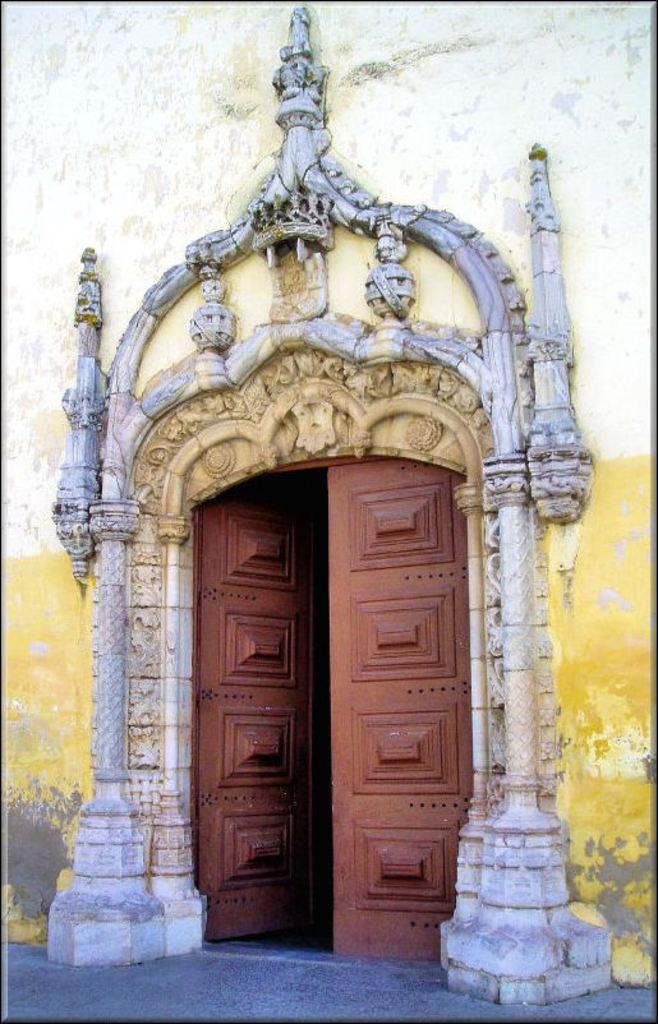What type of structure is visible in the image? There is a building in the image. Can you describe any specific features of the building? There is a door at the bottom of the building. How many marbles are placed on top of the building in the image? There are no marbles present on top of the building in the image. 